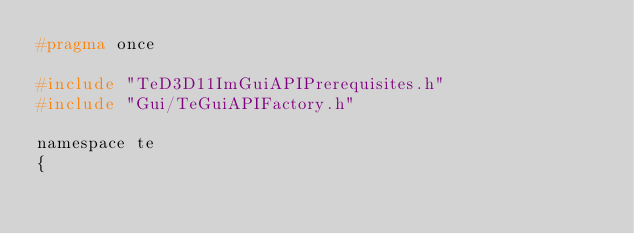<code> <loc_0><loc_0><loc_500><loc_500><_C_>#pragma once

#include "TeD3D11ImGuiAPIPrerequisites.h"
#include "Gui/TeGuiAPIFactory.h"

namespace te
{</code> 